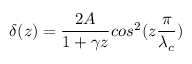Convert formula to latex. <formula><loc_0><loc_0><loc_500><loc_500>\delta ( z ) = \frac { 2 A } { 1 + \gamma z } \cos ^ { 2 } ( z \frac { \pi } { \lambda _ { c } } )</formula> 